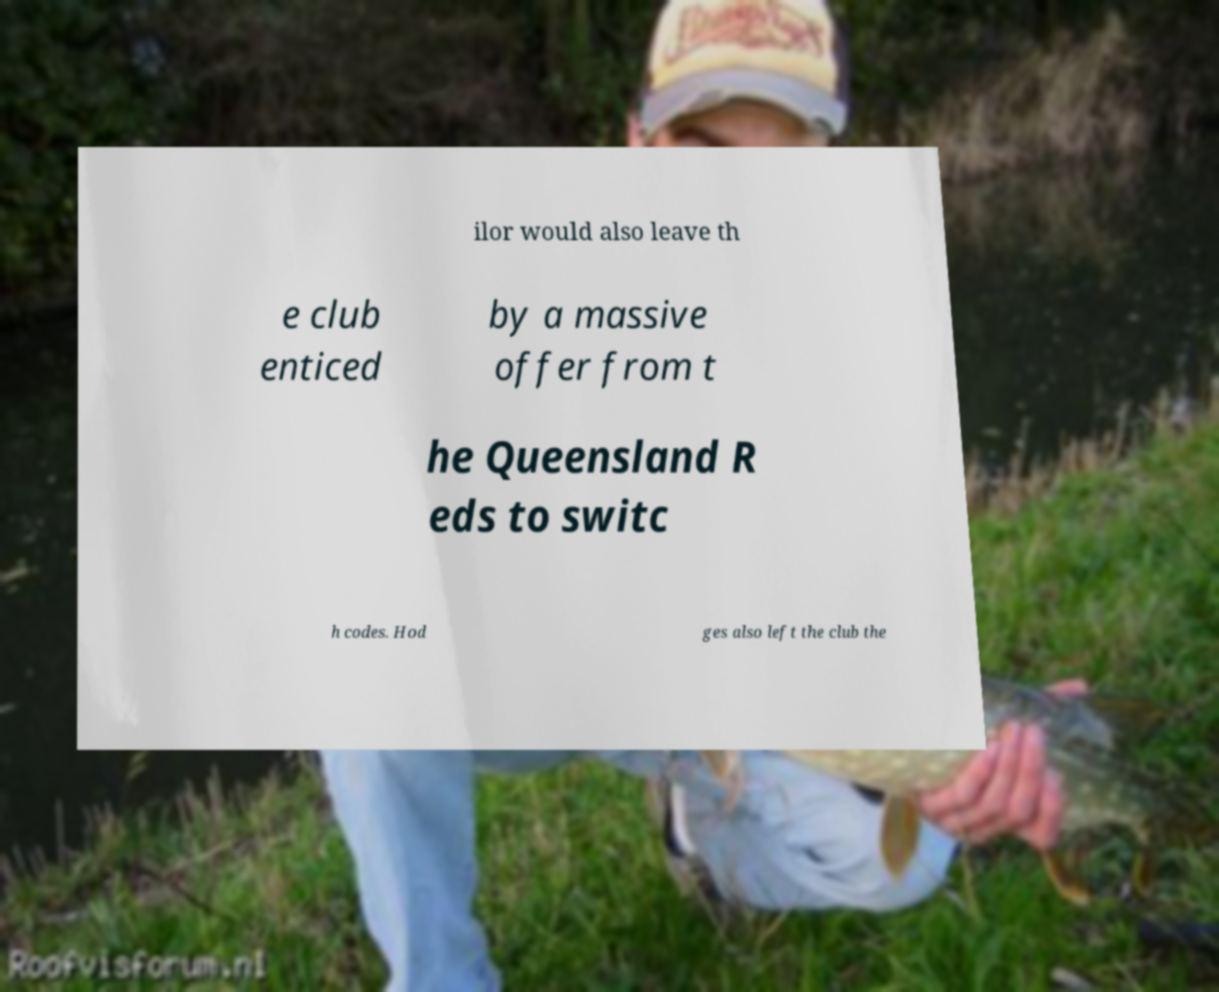Could you extract and type out the text from this image? ilor would also leave th e club enticed by a massive offer from t he Queensland R eds to switc h codes. Hod ges also left the club the 